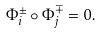Convert formula to latex. <formula><loc_0><loc_0><loc_500><loc_500>\Phi ^ { \pm } _ { i } \circ \Phi ^ { \mp } _ { j } = 0 .</formula> 